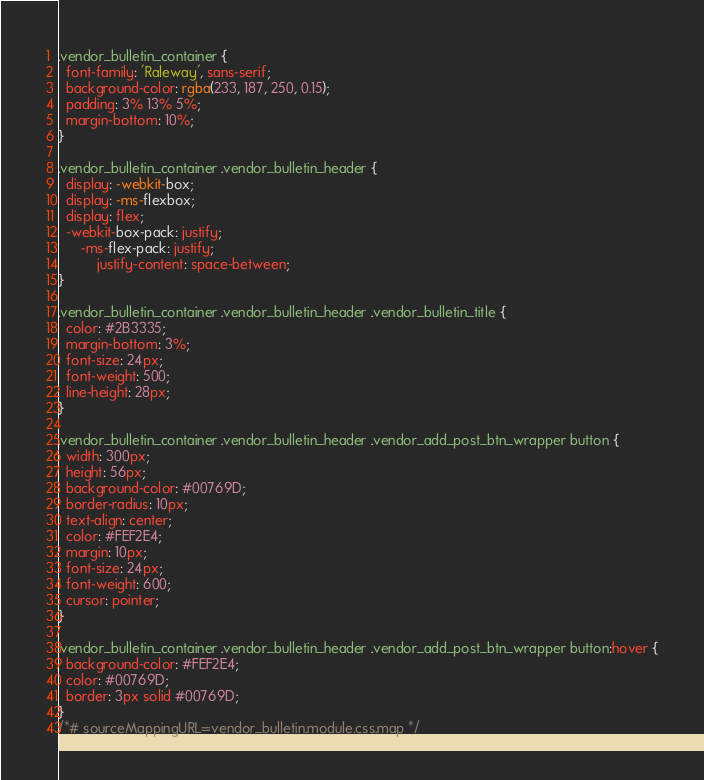<code> <loc_0><loc_0><loc_500><loc_500><_CSS_>.vendor_bulletin_container {
  font-family: 'Raleway', sans-serif;
  background-color: rgba(233, 187, 250, 0.15);
  padding: 3% 13% 5%;
  margin-bottom: 10%;
}

.vendor_bulletin_container .vendor_bulletin_header {
  display: -webkit-box;
  display: -ms-flexbox;
  display: flex;
  -webkit-box-pack: justify;
      -ms-flex-pack: justify;
          justify-content: space-between;
}

.vendor_bulletin_container .vendor_bulletin_header .vendor_bulletin_title {
  color: #2B3335;
  margin-bottom: 3%;
  font-size: 24px;
  font-weight: 500;
  line-height: 28px;
}

.vendor_bulletin_container .vendor_bulletin_header .vendor_add_post_btn_wrapper button {
  width: 300px;
  height: 56px;
  background-color: #00769D;
  border-radius: 10px;
  text-align: center;
  color: #FEF2E4;
  margin: 10px;
  font-size: 24px;
  font-weight: 600;
  cursor: pointer;
}

.vendor_bulletin_container .vendor_bulletin_header .vendor_add_post_btn_wrapper button:hover {
  background-color: #FEF2E4;
  color: #00769D;
  border: 3px solid #00769D;
}
/*# sourceMappingURL=vendor_bulletin.module.css.map */</code> 